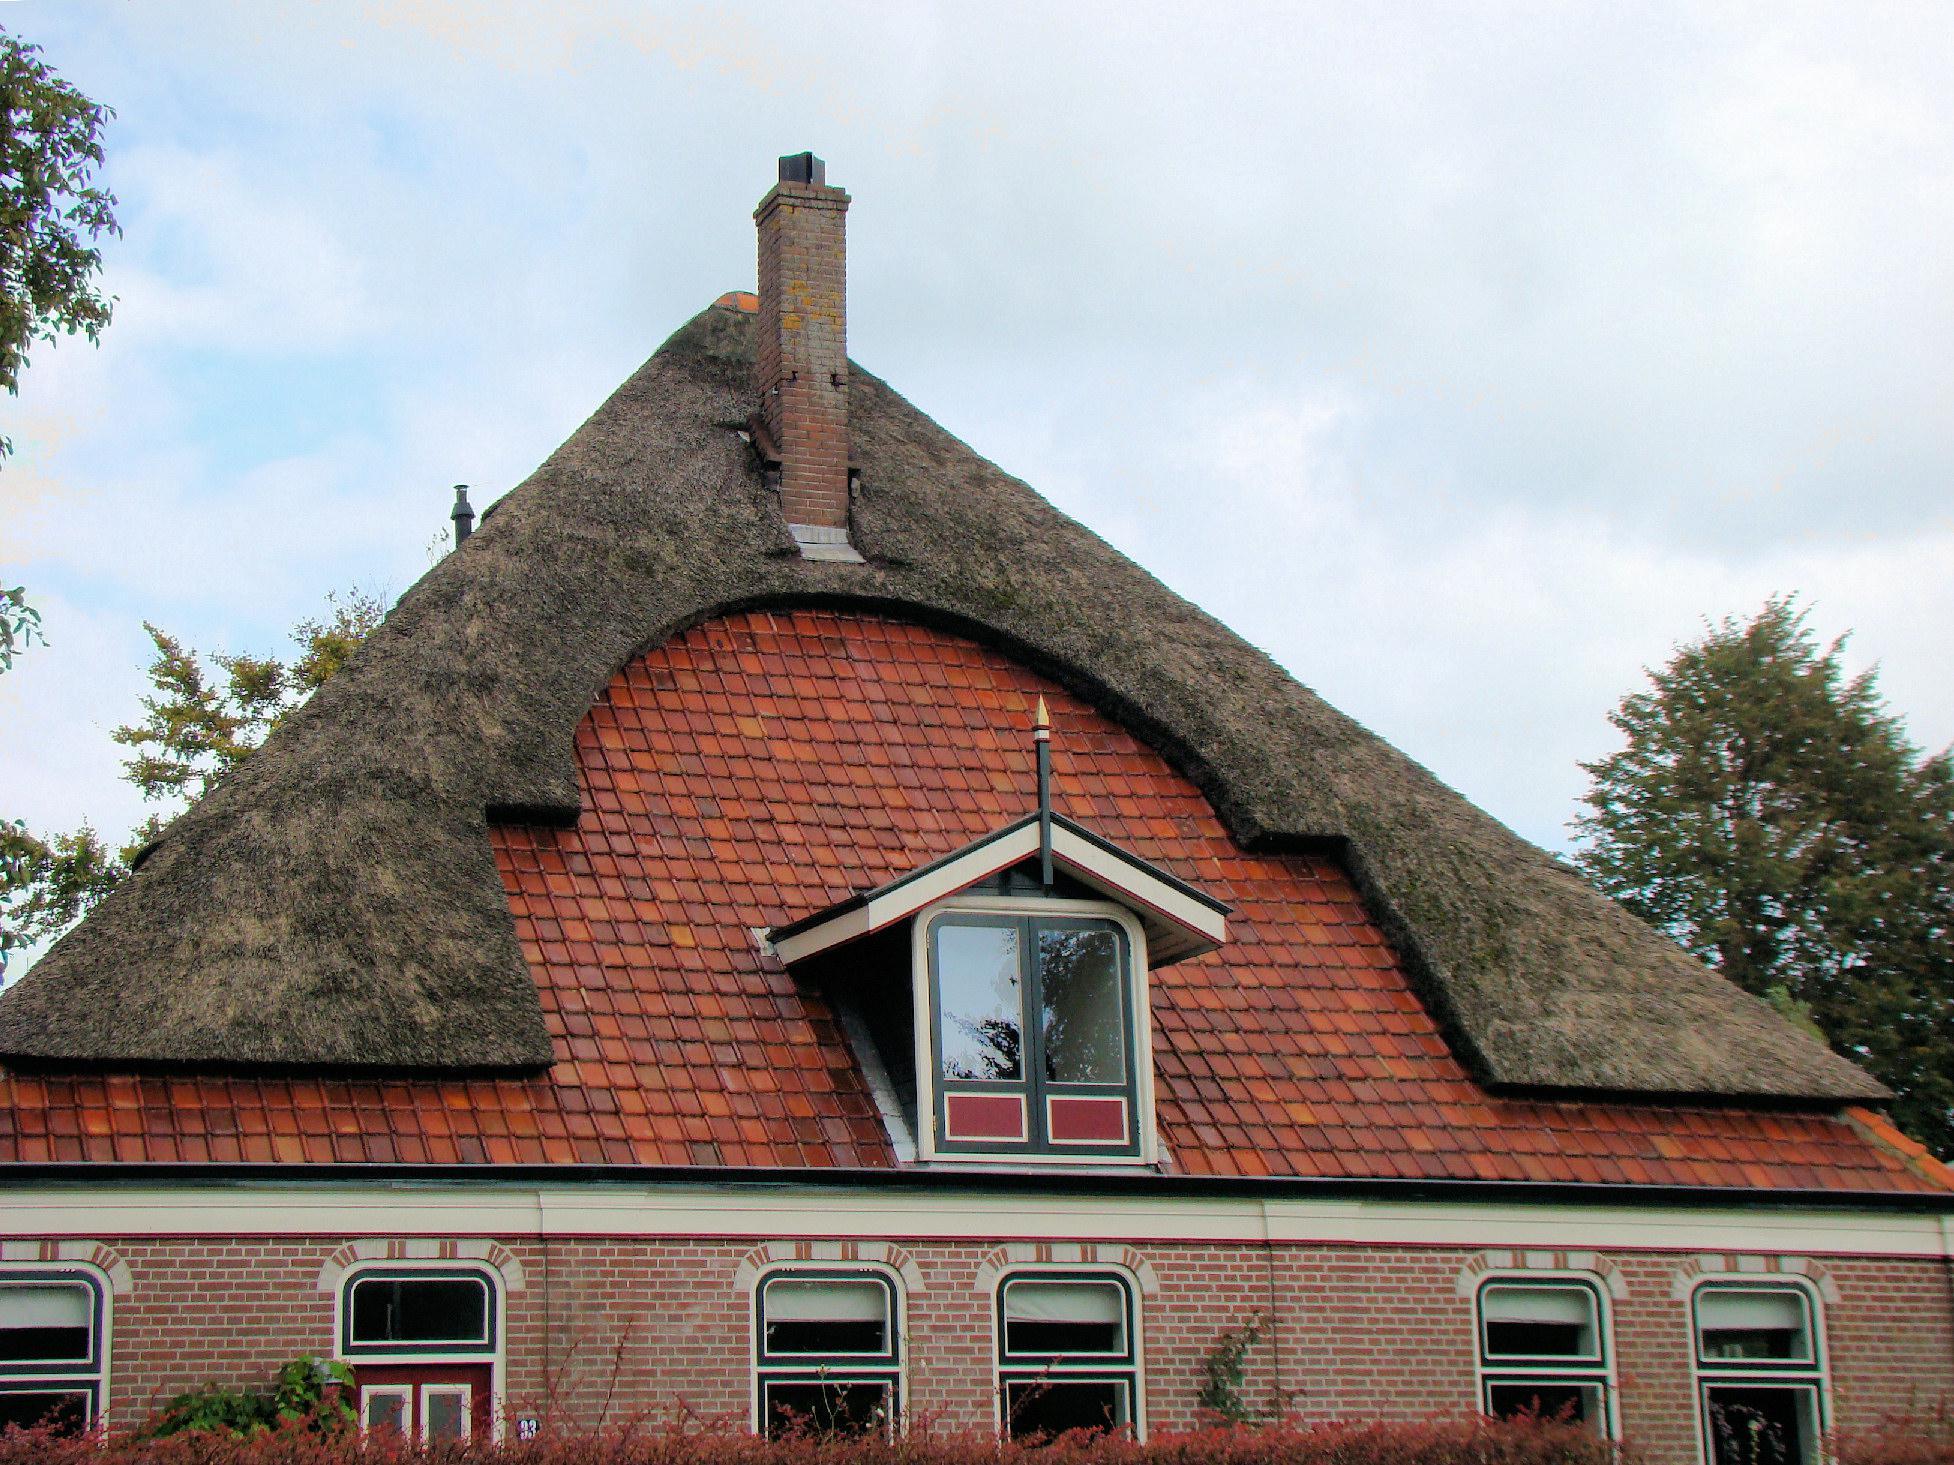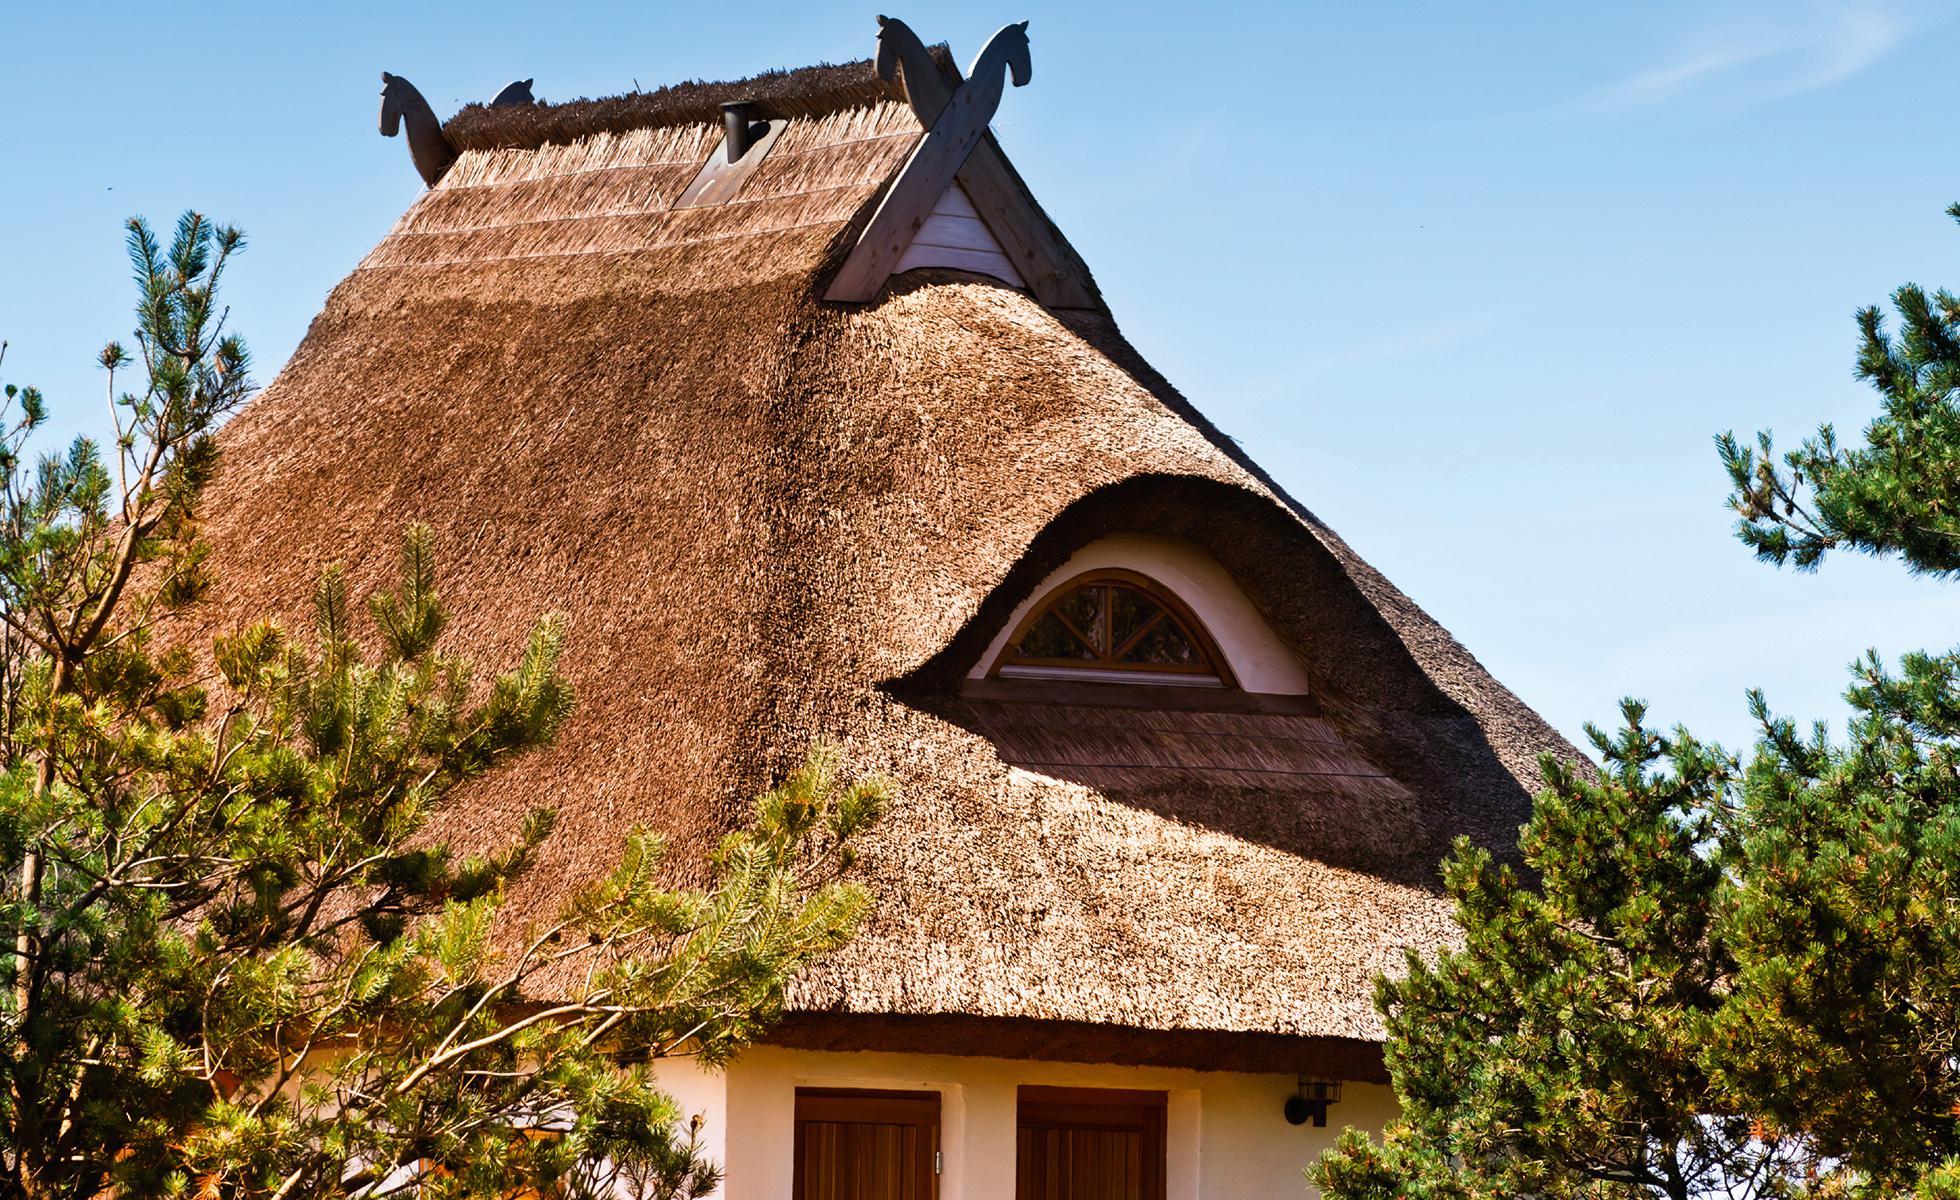The first image is the image on the left, the second image is the image on the right. Evaluate the accuracy of this statement regarding the images: "An image shows a chimney-less roof that curves around an upper window, creating a semicircle arch over it.". Is it true? Answer yes or no. Yes. The first image is the image on the left, the second image is the image on the right. Considering the images on both sides, is "In at least one image there is a a home with it's walls in red brick with at least three windows and one  chimney." valid? Answer yes or no. Yes. 